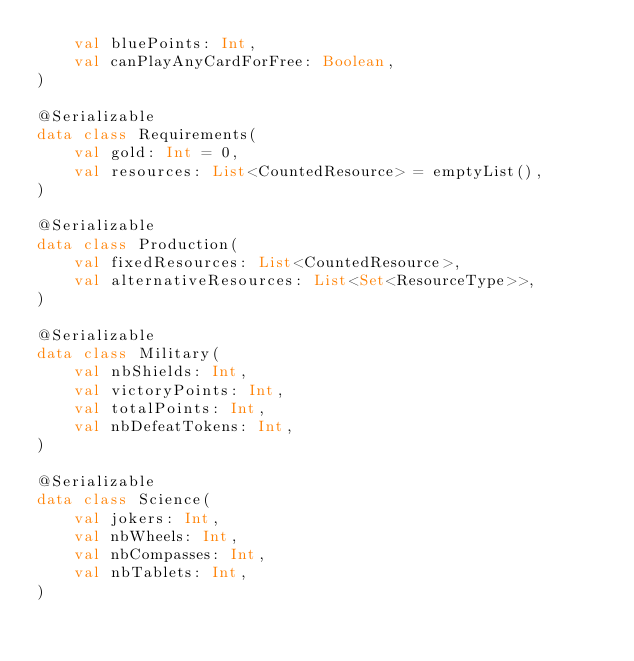Convert code to text. <code><loc_0><loc_0><loc_500><loc_500><_Kotlin_>    val bluePoints: Int,
    val canPlayAnyCardForFree: Boolean,
)

@Serializable
data class Requirements(
    val gold: Int = 0,
    val resources: List<CountedResource> = emptyList(),
)

@Serializable
data class Production(
    val fixedResources: List<CountedResource>,
    val alternativeResources: List<Set<ResourceType>>,
)

@Serializable
data class Military(
    val nbShields: Int,
    val victoryPoints: Int,
    val totalPoints: Int,
    val nbDefeatTokens: Int,
)

@Serializable
data class Science(
    val jokers: Int,
    val nbWheels: Int,
    val nbCompasses: Int,
    val nbTablets: Int,
)
</code> 